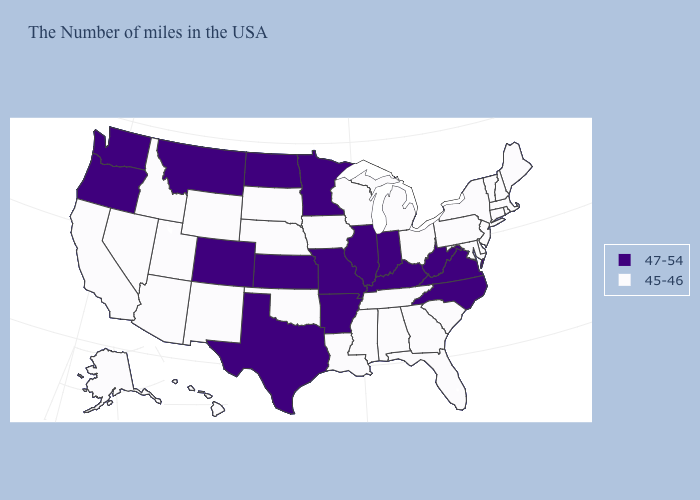What is the value of South Carolina?
Concise answer only. 45-46. What is the lowest value in the USA?
Be succinct. 45-46. What is the highest value in the USA?
Short answer required. 47-54. What is the value of South Dakota?
Give a very brief answer. 45-46. Name the states that have a value in the range 47-54?
Write a very short answer. Virginia, North Carolina, West Virginia, Kentucky, Indiana, Illinois, Missouri, Arkansas, Minnesota, Kansas, Texas, North Dakota, Colorado, Montana, Washington, Oregon. Name the states that have a value in the range 47-54?
Give a very brief answer. Virginia, North Carolina, West Virginia, Kentucky, Indiana, Illinois, Missouri, Arkansas, Minnesota, Kansas, Texas, North Dakota, Colorado, Montana, Washington, Oregon. Which states have the lowest value in the MidWest?
Give a very brief answer. Ohio, Michigan, Wisconsin, Iowa, Nebraska, South Dakota. Name the states that have a value in the range 45-46?
Give a very brief answer. Maine, Massachusetts, Rhode Island, New Hampshire, Vermont, Connecticut, New York, New Jersey, Delaware, Maryland, Pennsylvania, South Carolina, Ohio, Florida, Georgia, Michigan, Alabama, Tennessee, Wisconsin, Mississippi, Louisiana, Iowa, Nebraska, Oklahoma, South Dakota, Wyoming, New Mexico, Utah, Arizona, Idaho, Nevada, California, Alaska, Hawaii. Among the states that border Illinois , which have the highest value?
Give a very brief answer. Kentucky, Indiana, Missouri. What is the value of Arizona?
Concise answer only. 45-46. What is the value of Maryland?
Keep it brief. 45-46. Which states have the highest value in the USA?
Concise answer only. Virginia, North Carolina, West Virginia, Kentucky, Indiana, Illinois, Missouri, Arkansas, Minnesota, Kansas, Texas, North Dakota, Colorado, Montana, Washington, Oregon. Which states have the lowest value in the USA?
Write a very short answer. Maine, Massachusetts, Rhode Island, New Hampshire, Vermont, Connecticut, New York, New Jersey, Delaware, Maryland, Pennsylvania, South Carolina, Ohio, Florida, Georgia, Michigan, Alabama, Tennessee, Wisconsin, Mississippi, Louisiana, Iowa, Nebraska, Oklahoma, South Dakota, Wyoming, New Mexico, Utah, Arizona, Idaho, Nevada, California, Alaska, Hawaii. Name the states that have a value in the range 45-46?
Keep it brief. Maine, Massachusetts, Rhode Island, New Hampshire, Vermont, Connecticut, New York, New Jersey, Delaware, Maryland, Pennsylvania, South Carolina, Ohio, Florida, Georgia, Michigan, Alabama, Tennessee, Wisconsin, Mississippi, Louisiana, Iowa, Nebraska, Oklahoma, South Dakota, Wyoming, New Mexico, Utah, Arizona, Idaho, Nevada, California, Alaska, Hawaii. What is the value of Connecticut?
Answer briefly. 45-46. 